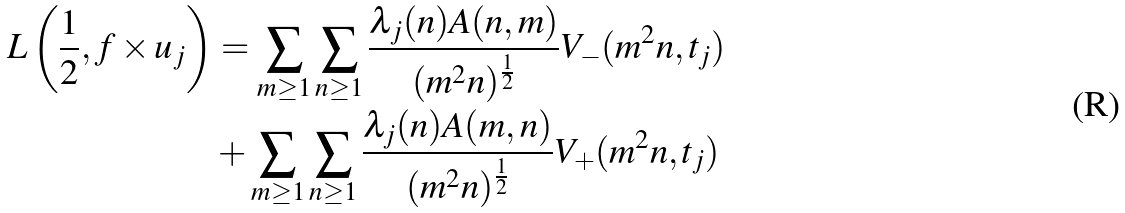Convert formula to latex. <formula><loc_0><loc_0><loc_500><loc_500>L \left ( \frac { 1 } { 2 } , f \times u _ { j } \right ) & = \sum _ { m \geq 1 } \sum _ { n \geq 1 } \frac { \lambda _ { j } ( n ) A ( n , m ) } { ( m ^ { 2 } n ) ^ { \frac { 1 } { 2 } } } V _ { - } ( m ^ { 2 } n , t _ { j } ) \\ & + \sum _ { m \geq 1 } \sum _ { n \geq 1 } \frac { \lambda _ { j } ( n ) A ( m , n ) } { ( m ^ { 2 } n ) ^ { \frac { 1 } { 2 } } } V _ { + } ( m ^ { 2 } n , t _ { j } )</formula> 